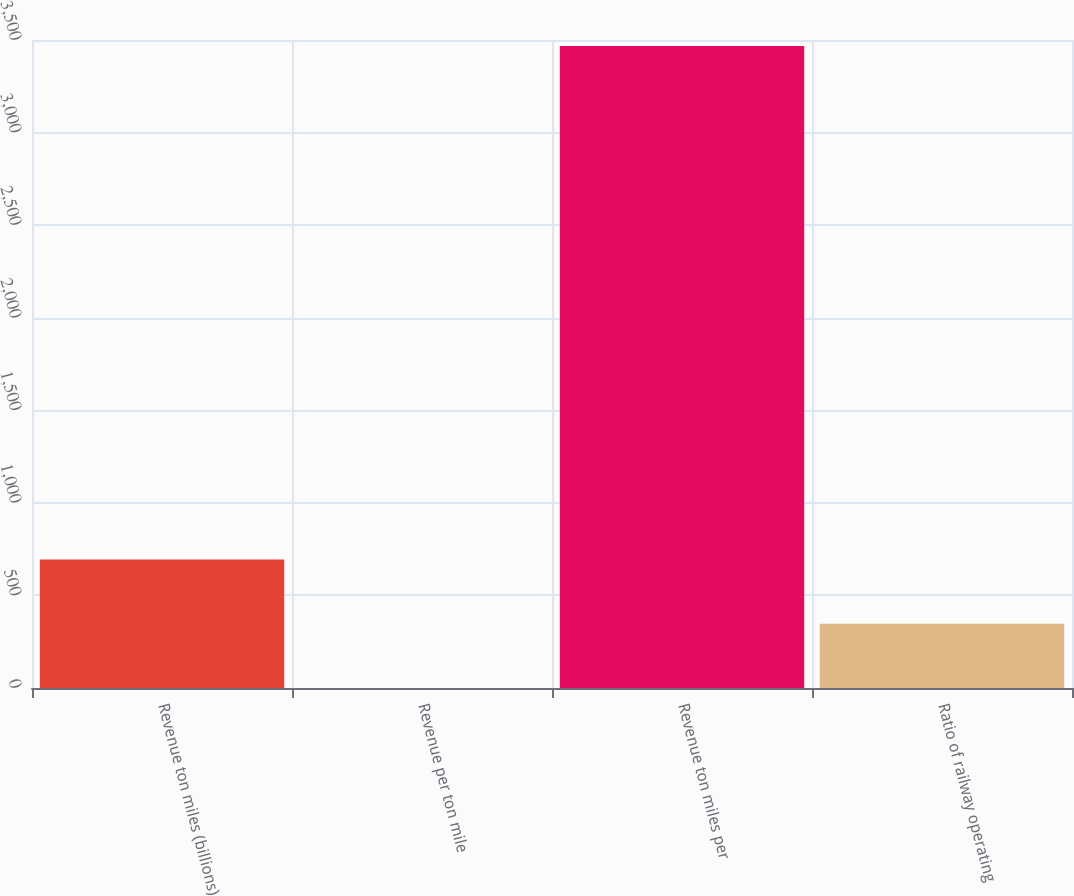Convert chart. <chart><loc_0><loc_0><loc_500><loc_500><bar_chart><fcel>Revenue ton miles (billions)<fcel>Revenue per ton mile<fcel>Revenue ton miles per<fcel>Ratio of railway operating<nl><fcel>693.44<fcel>0.05<fcel>3467<fcel>346.75<nl></chart> 